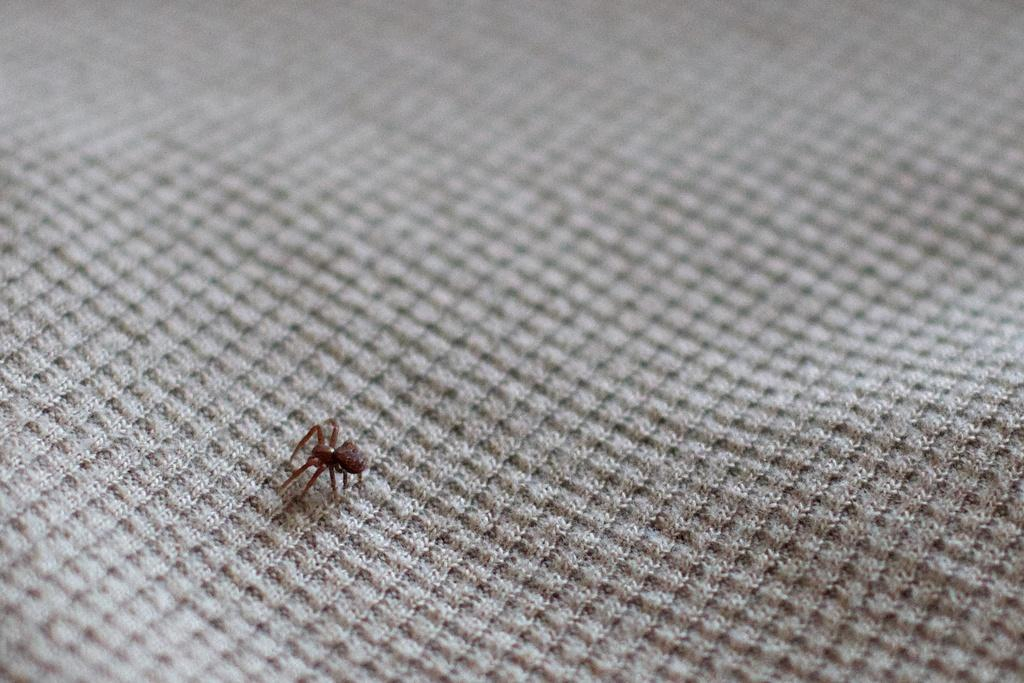What type of creature can be seen in the image? There is an insect in the image. Where is the insect located? The insect is on a cloth. What type of vest is the uncle wearing in the image? There is no uncle or vest present in the image; it only features an insect on a cloth. 